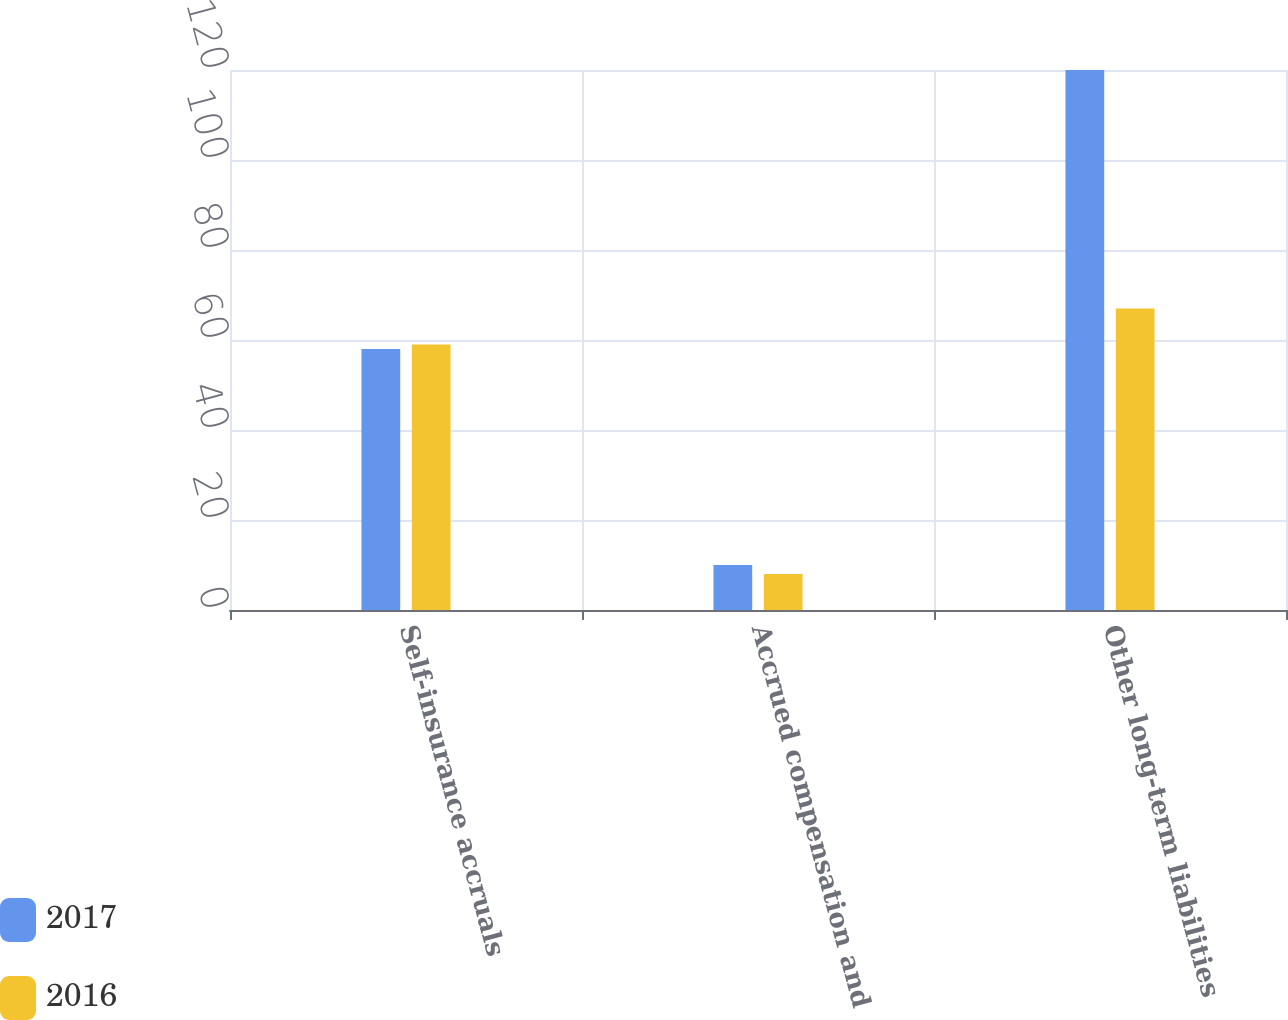Convert chart. <chart><loc_0><loc_0><loc_500><loc_500><stacked_bar_chart><ecel><fcel>Self-insurance accruals<fcel>Accrued compensation and<fcel>Other long-term liabilities<nl><fcel>2017<fcel>58<fcel>10<fcel>120<nl><fcel>2016<fcel>59<fcel>8<fcel>67<nl></chart> 